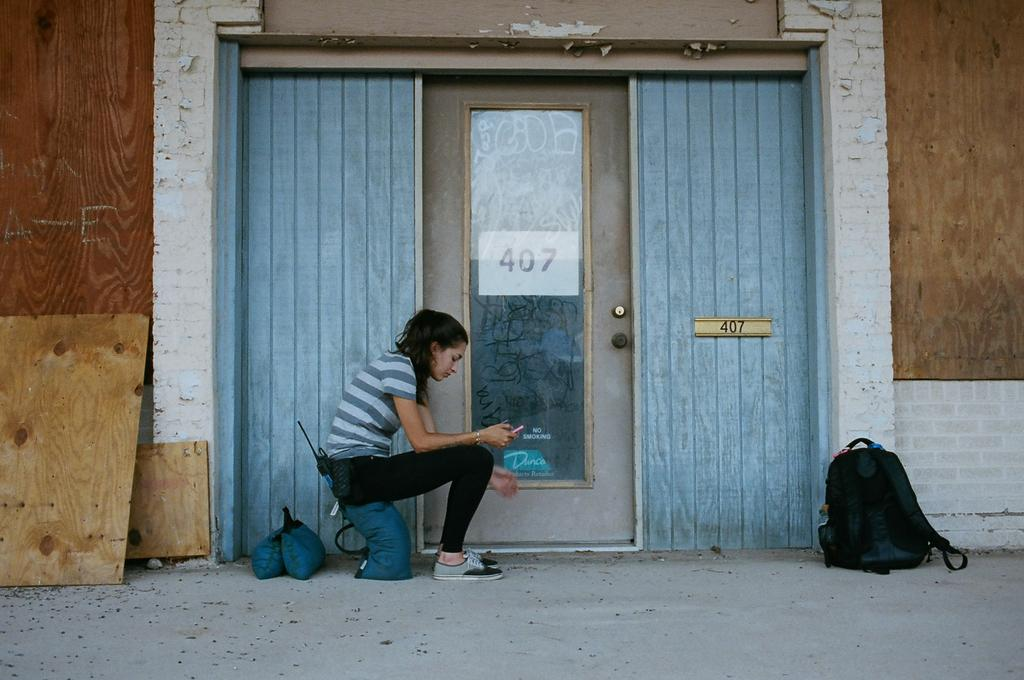Who is present in the image? There are women in the image. What object can be seen in the image? There is a bag in the image. What architectural feature is visible in the image? There is a door and a wall in the image. What material is used for the board in the image? There is a wooden board in the image. What surface is visible in the image? There is a floor in the image. Are there any water droplets visible on the wooden board in the image? There is no mention of water droplets or any liquid in the image, so we cannot determine if they are present. Can you see any cobwebs in the image? There is no mention of cobwebs or any spider webs in the image, so we cannot determine if they are present. 